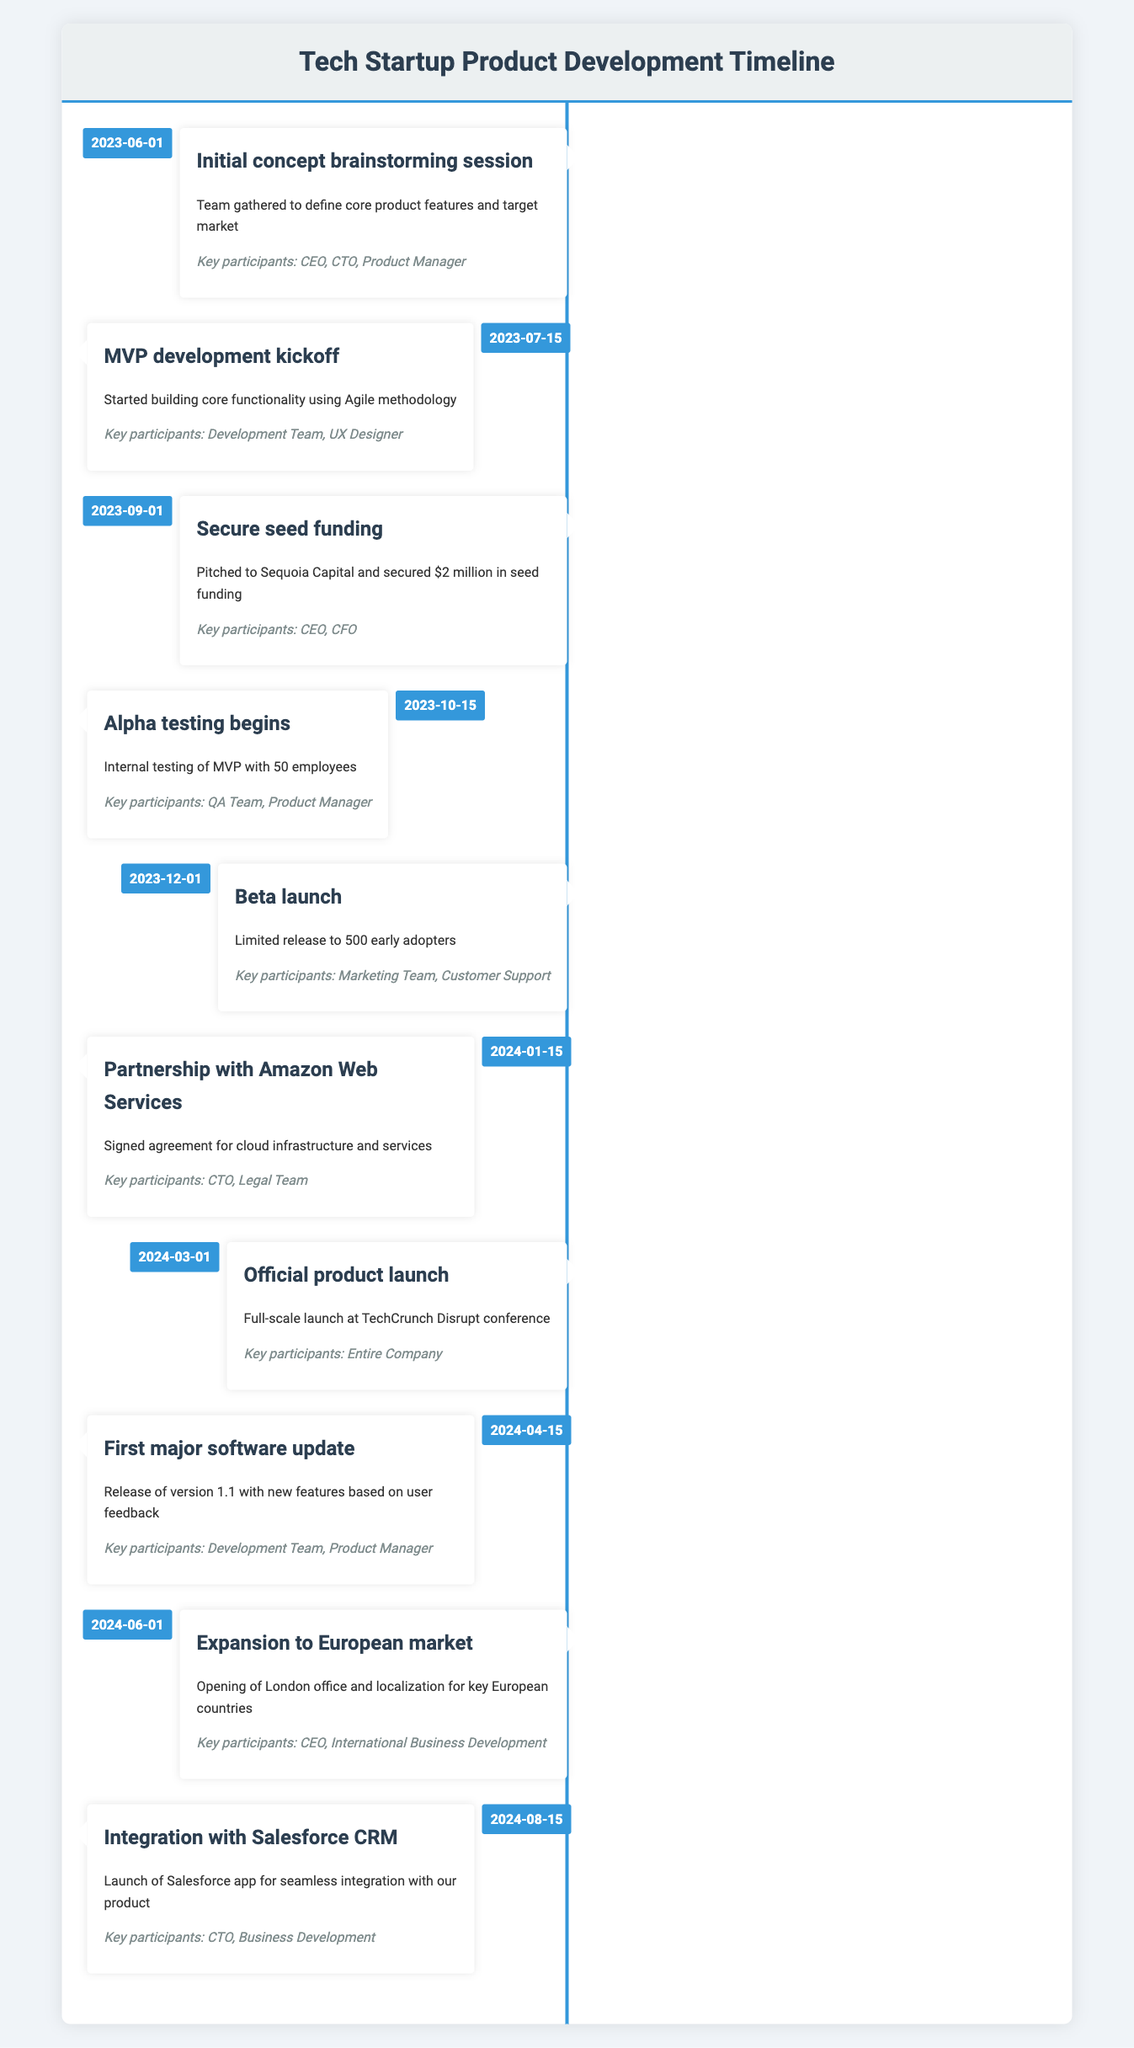What is the date of the MVP development kickoff? The milestone "MVP development kickoff" is listed with a date of "2023-07-15". This specific date can be found in the timeline under the corresponding milestone.
Answer: 2023-07-15 Who were the key participants in the beta launch? The "Beta launch" milestone shows that the key participants were the "Marketing Team" and "Customer Support". This information is explicitly stated in the details of that milestone.
Answer: Marketing Team, Customer Support Was alpha testing internally conducted? The milestone "Alpha testing begins" describes internal testing of the MVP, confirming that this testing was indeed conducted internally, as stated.
Answer: Yes How many phases of testing were there before the official product launch? The timeline shows two distinct phases mentioned: "Alpha testing begins" (on 2023-10-15) and "Beta launch" (on 2023-12-01). These represent the testing phases before the official product launch.
Answer: Two When was the first major software update released? The "First major software update" milestone indicates that it was released on "2024-04-15". This information can be directly retrieved from the timeline entry for that milestone.
Answer: 2024-04-15 What is the total number of key participants involved in the initial concept brainstorming session? The initial concept brainstorming session lists three key participants: "CEO", "CTO", and "Product Manager". Therefore, the total is simply three.
Answer: 3 Which milestone marks the partnership with Amazon Web Services, and what date is it scheduled? The milestone related to the partnership with Amazon Web Services is set for "2024-01-15". This is directly extracted from the timeline where that milestone is documented.
Answer: 2024-01-15 What was the total time span from the initial concept session to the official product launch? The initial concept brainstorming was on "2023-06-01" and the official product launch was on "2024-03-01". The time span can be calculated by finding the difference between these two dates, totaling approximately 9 months.
Answer: 9 months Which milestone involved a limited release to early adopters? The milestone "Beta launch", occurring on "2023-12-01", explicitly mentions a limited release to 500 early adopters. This fact is clearly stated in the milestone's description.
Answer: Beta launch 